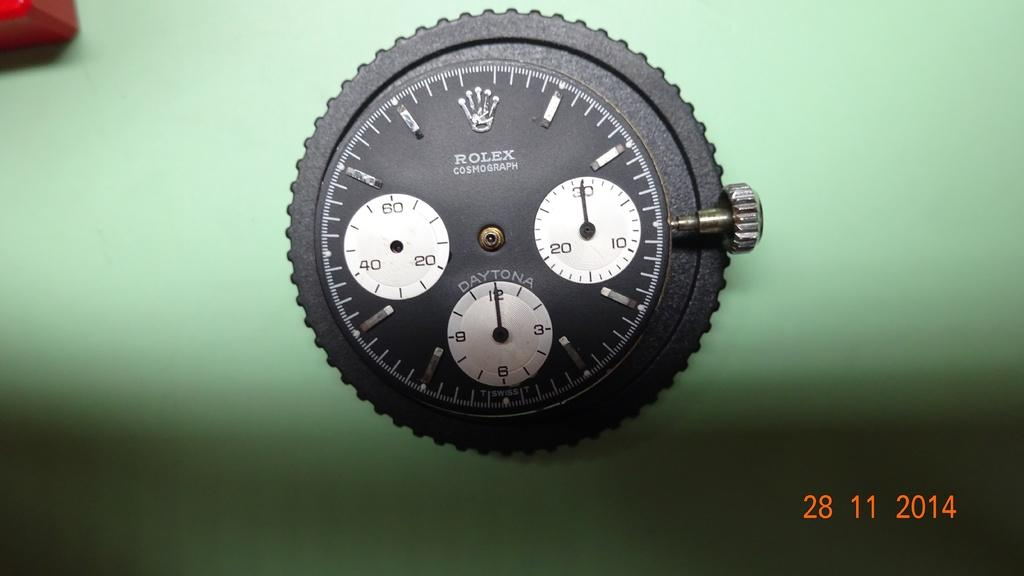What is the main subject of the image? The main subject of the image is a watch part. What can be seen on the watch part? There are numbers on the watch part. What color is the background of the image? The background of the image is green. Does the image appear to be altered or edited in any way? Yes, the image appears to be edited. How many passengers are visible in the image? There are no passengers present in the image; it features a watch part with numbers on it. What type of camp can be seen in the background of the image? There is no camp present in the image; the background is green. 